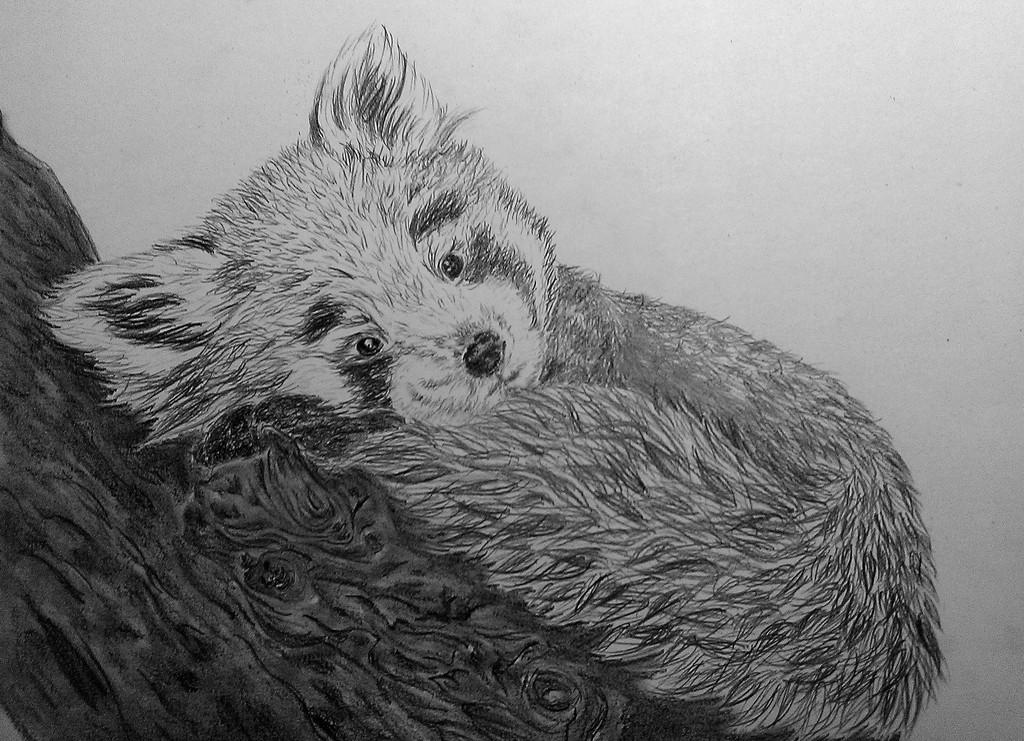What type of art medium is used in the image? The image is a pencil drawing. What is the subject of the drawing? The drawing depicts an animal. On what surface is the drawing created? The drawing is on a wood surface. What does the son learn from the drawing in the image? There is no son or learning depicted in the image; it is a pencil drawing of an animal on a wood surface. 